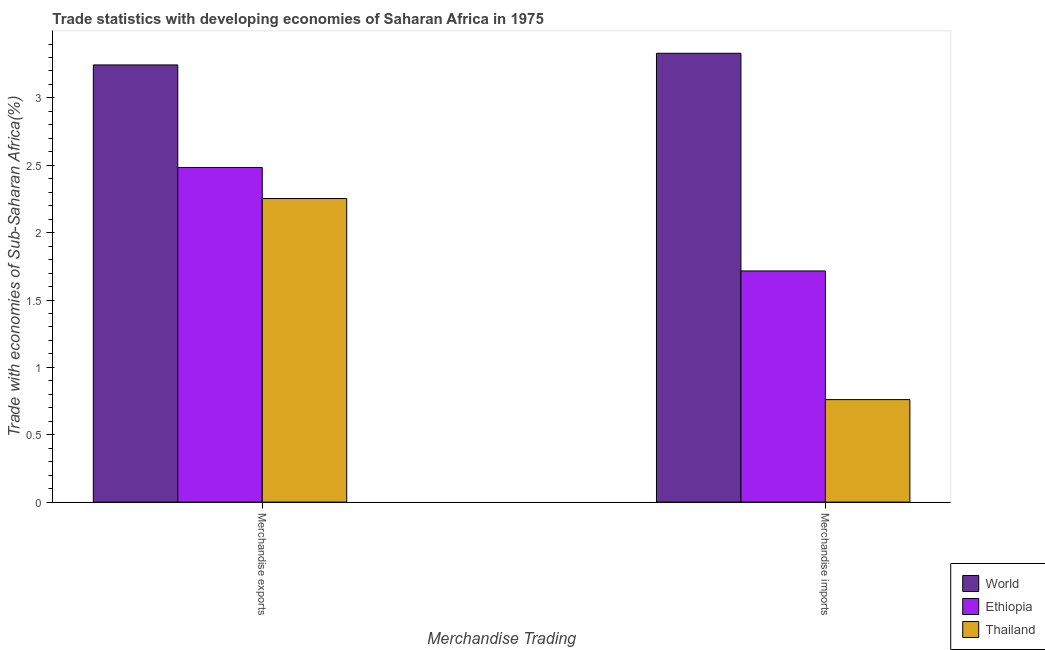How many different coloured bars are there?
Make the answer very short. 3. Are the number of bars per tick equal to the number of legend labels?
Provide a short and direct response. Yes. Are the number of bars on each tick of the X-axis equal?
Keep it short and to the point. Yes. What is the merchandise exports in Thailand?
Give a very brief answer. 2.25. Across all countries, what is the maximum merchandise imports?
Your response must be concise. 3.33. Across all countries, what is the minimum merchandise imports?
Provide a short and direct response. 0.76. In which country was the merchandise imports maximum?
Your answer should be very brief. World. In which country was the merchandise imports minimum?
Your answer should be very brief. Thailand. What is the total merchandise imports in the graph?
Make the answer very short. 5.81. What is the difference between the merchandise imports in World and that in Ethiopia?
Your answer should be very brief. 1.62. What is the difference between the merchandise exports in Ethiopia and the merchandise imports in Thailand?
Ensure brevity in your answer.  1.72. What is the average merchandise imports per country?
Ensure brevity in your answer.  1.94. What is the difference between the merchandise imports and merchandise exports in World?
Keep it short and to the point. 0.09. What is the ratio of the merchandise imports in Ethiopia to that in World?
Offer a terse response. 0.52. In how many countries, is the merchandise exports greater than the average merchandise exports taken over all countries?
Provide a succinct answer. 1. What does the 3rd bar from the left in Merchandise imports represents?
Give a very brief answer. Thailand. What does the 2nd bar from the right in Merchandise imports represents?
Make the answer very short. Ethiopia. Are all the bars in the graph horizontal?
Keep it short and to the point. No. How many countries are there in the graph?
Offer a terse response. 3. How are the legend labels stacked?
Your answer should be compact. Vertical. What is the title of the graph?
Provide a succinct answer. Trade statistics with developing economies of Saharan Africa in 1975. What is the label or title of the X-axis?
Ensure brevity in your answer.  Merchandise Trading. What is the label or title of the Y-axis?
Your response must be concise. Trade with economies of Sub-Saharan Africa(%). What is the Trade with economies of Sub-Saharan Africa(%) of World in Merchandise exports?
Provide a succinct answer. 3.24. What is the Trade with economies of Sub-Saharan Africa(%) of Ethiopia in Merchandise exports?
Keep it short and to the point. 2.48. What is the Trade with economies of Sub-Saharan Africa(%) of Thailand in Merchandise exports?
Provide a succinct answer. 2.25. What is the Trade with economies of Sub-Saharan Africa(%) of World in Merchandise imports?
Ensure brevity in your answer.  3.33. What is the Trade with economies of Sub-Saharan Africa(%) of Ethiopia in Merchandise imports?
Give a very brief answer. 1.72. What is the Trade with economies of Sub-Saharan Africa(%) in Thailand in Merchandise imports?
Provide a short and direct response. 0.76. Across all Merchandise Trading, what is the maximum Trade with economies of Sub-Saharan Africa(%) of World?
Ensure brevity in your answer.  3.33. Across all Merchandise Trading, what is the maximum Trade with economies of Sub-Saharan Africa(%) of Ethiopia?
Offer a very short reply. 2.48. Across all Merchandise Trading, what is the maximum Trade with economies of Sub-Saharan Africa(%) of Thailand?
Keep it short and to the point. 2.25. Across all Merchandise Trading, what is the minimum Trade with economies of Sub-Saharan Africa(%) in World?
Make the answer very short. 3.24. Across all Merchandise Trading, what is the minimum Trade with economies of Sub-Saharan Africa(%) of Ethiopia?
Make the answer very short. 1.72. Across all Merchandise Trading, what is the minimum Trade with economies of Sub-Saharan Africa(%) of Thailand?
Ensure brevity in your answer.  0.76. What is the total Trade with economies of Sub-Saharan Africa(%) in World in the graph?
Provide a succinct answer. 6.58. What is the total Trade with economies of Sub-Saharan Africa(%) in Ethiopia in the graph?
Offer a very short reply. 4.2. What is the total Trade with economies of Sub-Saharan Africa(%) in Thailand in the graph?
Your answer should be very brief. 3.01. What is the difference between the Trade with economies of Sub-Saharan Africa(%) in World in Merchandise exports and that in Merchandise imports?
Make the answer very short. -0.09. What is the difference between the Trade with economies of Sub-Saharan Africa(%) of Ethiopia in Merchandise exports and that in Merchandise imports?
Offer a terse response. 0.77. What is the difference between the Trade with economies of Sub-Saharan Africa(%) in Thailand in Merchandise exports and that in Merchandise imports?
Offer a terse response. 1.49. What is the difference between the Trade with economies of Sub-Saharan Africa(%) in World in Merchandise exports and the Trade with economies of Sub-Saharan Africa(%) in Ethiopia in Merchandise imports?
Keep it short and to the point. 1.53. What is the difference between the Trade with economies of Sub-Saharan Africa(%) of World in Merchandise exports and the Trade with economies of Sub-Saharan Africa(%) of Thailand in Merchandise imports?
Provide a succinct answer. 2.48. What is the difference between the Trade with economies of Sub-Saharan Africa(%) in Ethiopia in Merchandise exports and the Trade with economies of Sub-Saharan Africa(%) in Thailand in Merchandise imports?
Keep it short and to the point. 1.72. What is the average Trade with economies of Sub-Saharan Africa(%) in World per Merchandise Trading?
Keep it short and to the point. 3.29. What is the average Trade with economies of Sub-Saharan Africa(%) in Ethiopia per Merchandise Trading?
Your answer should be very brief. 2.1. What is the average Trade with economies of Sub-Saharan Africa(%) in Thailand per Merchandise Trading?
Offer a terse response. 1.51. What is the difference between the Trade with economies of Sub-Saharan Africa(%) of World and Trade with economies of Sub-Saharan Africa(%) of Ethiopia in Merchandise exports?
Ensure brevity in your answer.  0.76. What is the difference between the Trade with economies of Sub-Saharan Africa(%) in World and Trade with economies of Sub-Saharan Africa(%) in Thailand in Merchandise exports?
Keep it short and to the point. 0.99. What is the difference between the Trade with economies of Sub-Saharan Africa(%) of Ethiopia and Trade with economies of Sub-Saharan Africa(%) of Thailand in Merchandise exports?
Provide a succinct answer. 0.23. What is the difference between the Trade with economies of Sub-Saharan Africa(%) in World and Trade with economies of Sub-Saharan Africa(%) in Ethiopia in Merchandise imports?
Give a very brief answer. 1.62. What is the difference between the Trade with economies of Sub-Saharan Africa(%) of World and Trade with economies of Sub-Saharan Africa(%) of Thailand in Merchandise imports?
Your answer should be very brief. 2.57. What is the difference between the Trade with economies of Sub-Saharan Africa(%) in Ethiopia and Trade with economies of Sub-Saharan Africa(%) in Thailand in Merchandise imports?
Your answer should be compact. 0.95. What is the ratio of the Trade with economies of Sub-Saharan Africa(%) in World in Merchandise exports to that in Merchandise imports?
Provide a succinct answer. 0.97. What is the ratio of the Trade with economies of Sub-Saharan Africa(%) of Ethiopia in Merchandise exports to that in Merchandise imports?
Provide a succinct answer. 1.45. What is the ratio of the Trade with economies of Sub-Saharan Africa(%) of Thailand in Merchandise exports to that in Merchandise imports?
Provide a succinct answer. 2.96. What is the difference between the highest and the second highest Trade with economies of Sub-Saharan Africa(%) in World?
Your answer should be very brief. 0.09. What is the difference between the highest and the second highest Trade with economies of Sub-Saharan Africa(%) in Ethiopia?
Your answer should be compact. 0.77. What is the difference between the highest and the second highest Trade with economies of Sub-Saharan Africa(%) of Thailand?
Provide a short and direct response. 1.49. What is the difference between the highest and the lowest Trade with economies of Sub-Saharan Africa(%) of World?
Your answer should be compact. 0.09. What is the difference between the highest and the lowest Trade with economies of Sub-Saharan Africa(%) of Ethiopia?
Your answer should be compact. 0.77. What is the difference between the highest and the lowest Trade with economies of Sub-Saharan Africa(%) in Thailand?
Give a very brief answer. 1.49. 